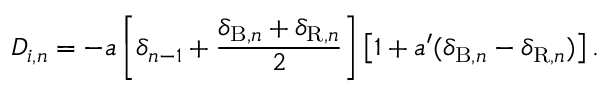Convert formula to latex. <formula><loc_0><loc_0><loc_500><loc_500>D _ { i , n } = - a \left [ \delta _ { n - 1 } + \frac { \delta _ { B , n } + \delta _ { R , n } } { 2 } \right ] \left [ 1 + a ^ { \prime } ( \delta _ { B , n } - \delta _ { R , n } ) \right ] .</formula> 